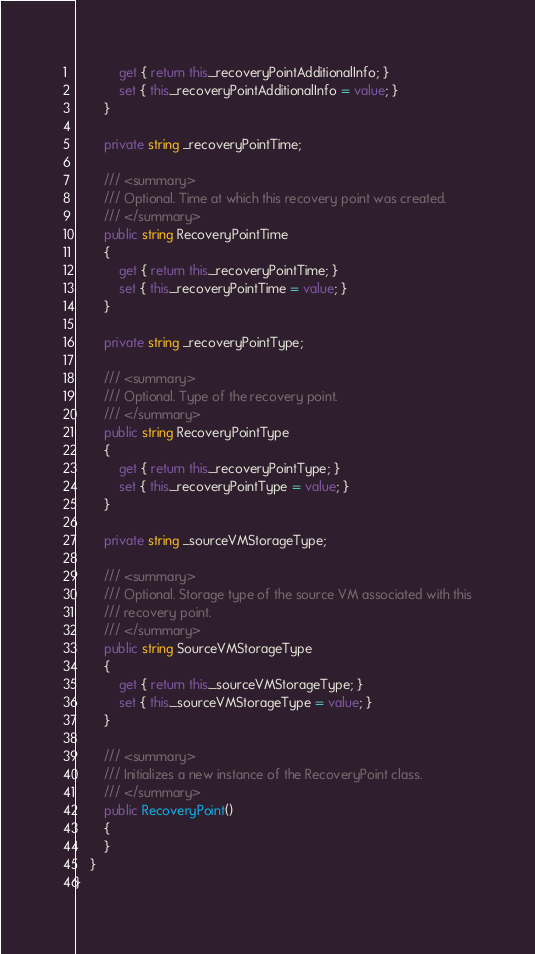<code> <loc_0><loc_0><loc_500><loc_500><_C#_>            get { return this._recoveryPointAdditionalInfo; }
            set { this._recoveryPointAdditionalInfo = value; }
        }
        
        private string _recoveryPointTime;
        
        /// <summary>
        /// Optional. Time at which this recovery point was created.
        /// </summary>
        public string RecoveryPointTime
        {
            get { return this._recoveryPointTime; }
            set { this._recoveryPointTime = value; }
        }
        
        private string _recoveryPointType;
        
        /// <summary>
        /// Optional. Type of the recovery point.
        /// </summary>
        public string RecoveryPointType
        {
            get { return this._recoveryPointType; }
            set { this._recoveryPointType = value; }
        }
        
        private string _sourceVMStorageType;
        
        /// <summary>
        /// Optional. Storage type of the source VM associated with this
        /// recovery point.
        /// </summary>
        public string SourceVMStorageType
        {
            get { return this._sourceVMStorageType; }
            set { this._sourceVMStorageType = value; }
        }
        
        /// <summary>
        /// Initializes a new instance of the RecoveryPoint class.
        /// </summary>
        public RecoveryPoint()
        {
        }
    }
}
</code> 